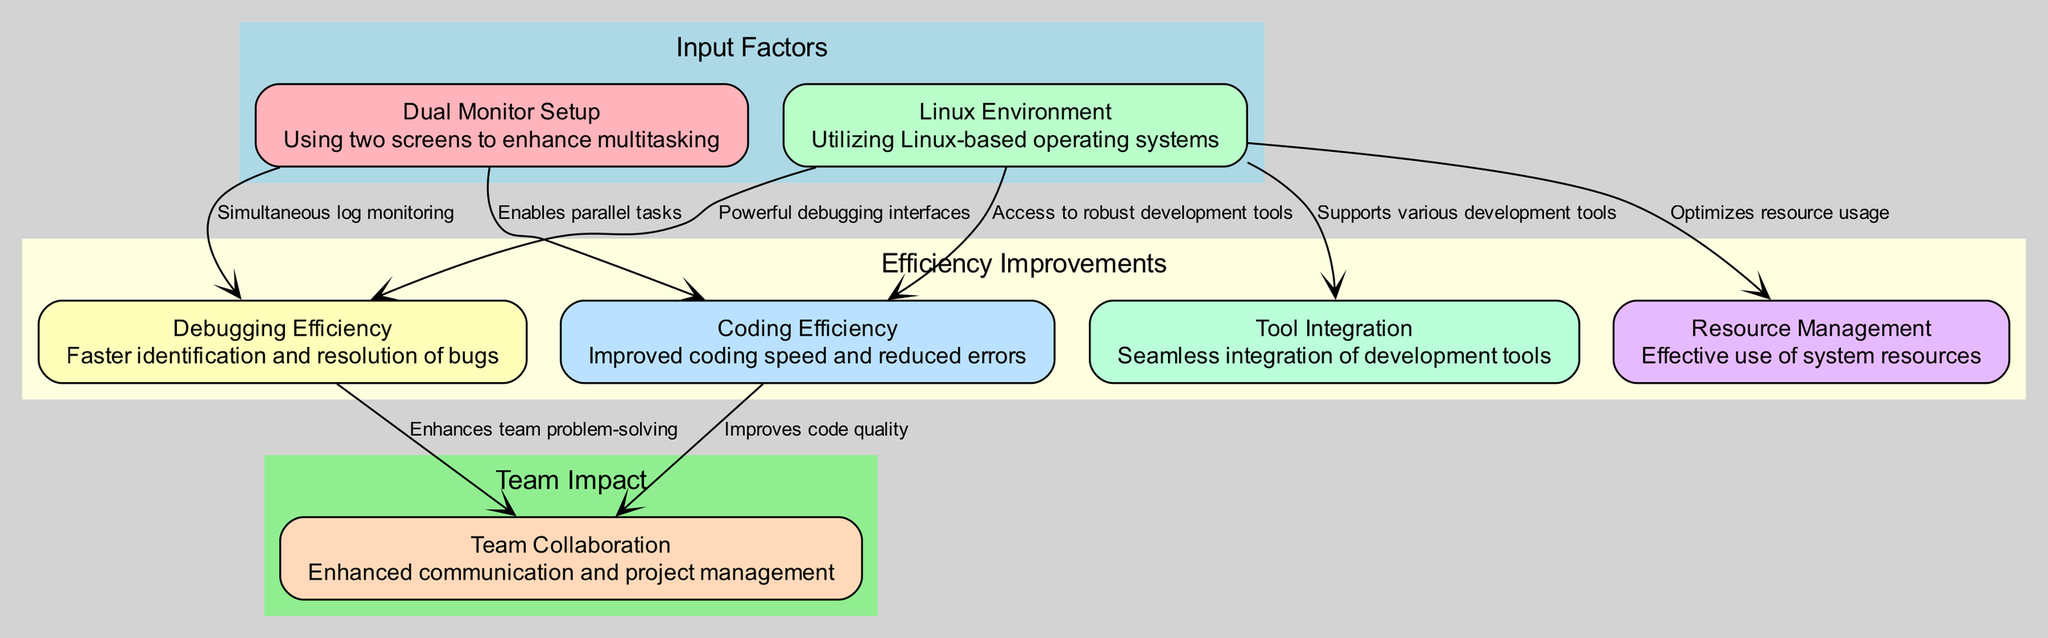What are the input factors in the diagram? The input factors are represented in the cluster labeled "Input Factors", which includes the nodes "Dual Monitor Setup" and "Linux Environment".
Answer: Dual Monitor Setup, Linux Environment How many nodes are there in total? The diagram contains a total of 7 nodes including the following: Dual Monitor Setup, Linux Environment, Coding Efficiency, Debugging Efficiency, Collaboration, Resource Management, and Tool Integration. Counting them gives us a total of 7.
Answer: 7 What is the relationship between Dual Monitor Setup and Debugging Efficiency? The edge from "Dual Monitor Setup" to "Debugging Efficiency" indicates that it allows for simultaneous log monitoring, signifying a direct influence on debugging effectiveness.
Answer: Simultaneous log monitoring Which node is linked to the most edges? By analyzing the edges, "Linux Environment" is linked to 4 other nodes (Coding Efficiency, Debugging Efficiency, Resource Management, Tool Integration), making it the most connected node in the diagram.
Answer: Linux Environment How does Coding Efficiency lead to Collaboration? There is an edge leading from "Coding Efficiency" to "Collaboration" indicating that improved code quality from coding efficiency facilitates better teamwork and communication within the engineering team.
Answer: Improves code quality What is the impact of Linux Environment on Resource Management? The edge from "Linux Environment" to "Resource Management" states that it optimizes resource usage, suggesting that using a Linux Environment contributes positively to managing system resources.
Answer: Optimizes resource usage How many edges are showing relationships between input factors and efficiency improvements? There are 4 edges showing relationships, specifically linking the input factors (Dual Monitors and Linux Environment) to the efficiency improvements (Coding Efficiency and Debugging Efficiency).
Answer: 4 What does Tool Integration support? The edge from "Linux Environment" to "Tool Integration" indicates that it supports various development tools, highlighting the role of Linux environments in providing necessary integrations for efficient work.
Answer: Supports various development tools Which efficiency improvement enhances team problem-solving? The edge from "Debugging Efficiency" to "Collaboration" indicates that enhanced debugging processes help the team in solving problems more effectively.
Answer: Enhances team problem-solving 